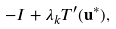<formula> <loc_0><loc_0><loc_500><loc_500>- I + \lambda _ { k } T ^ { \prime } ( { \mathbf u } ^ { * } ) ,</formula> 